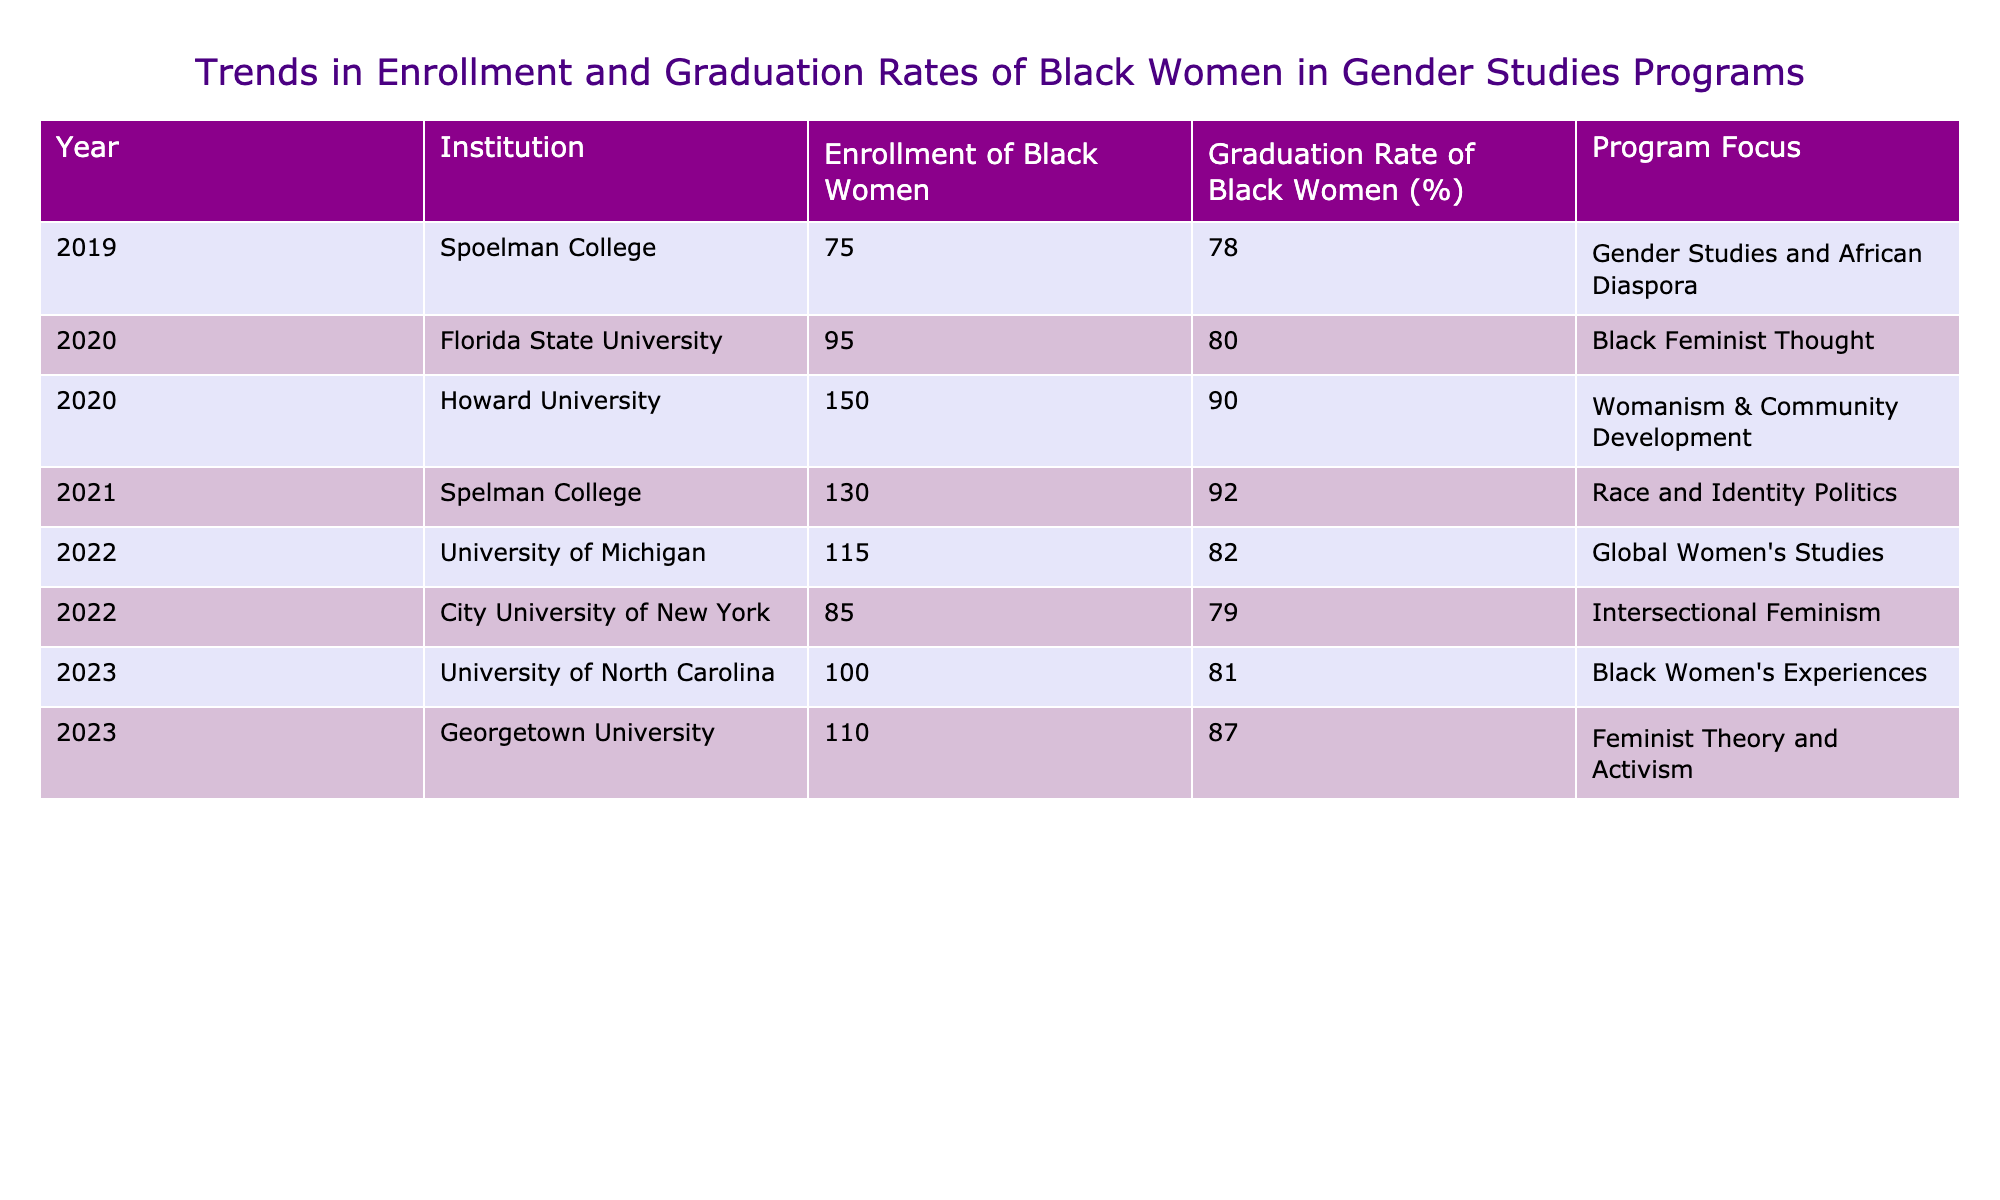What is the enrollment of Black women at Howard University in 2020? The table indicates that in the year 2020, Howard University had an enrollment of 150 Black women.
Answer: 150 What is the graduation rate of Black women at Spelman College in 2021? According to the table, the graduation rate of Black women at Spelman College in 2021 was 92%.
Answer: 92% Which program had the highest graduation rate among the institutions in 2023? The table shows that in 2023, Georgetown University had the highest graduation rate of 87% for Black women.
Answer: 87% What is the average enrollment of Black women across all institutions from 2019 to 2023? To find the average enrollment, we sum the enrollment figures: 75 + 95 + 150 + 130 + 115 + 85 + 100 + 110 = 960. Since there are 8 data points, the average is 960 / 8 = 120.
Answer: 120 Did any institution have a graduation rate of 80% or higher in 2020? By checking the table, it is found that Florida State University (80%) and Howard University (90%) both had graduation rates of 80% or higher in 2020.
Answer: Yes Which institution had the lowest enrollment of Black women in the provided years? The table shows that City University of New York had the lowest enrollment of 85 Black women in 2022.
Answer: 85 Is there a trend of increasing graduation rates for Black women from 2019 to 2023? By analyzing the graduation rates from each year: 78%, 80%, 90%, 92%, 82%, 79%, 81%, 87%, it is observed that there is fluctuation but an overall upward trend from 2019 to 2023, considering the highest rates are in the later years.
Answer: Yes Which program focuses specifically on Black feminist thought and what was its graduation rate in 2020? The table indicates that Florida State University focuses on Black Feminist Thought, and its graduation rate in 2020 was 80%.
Answer: 80 